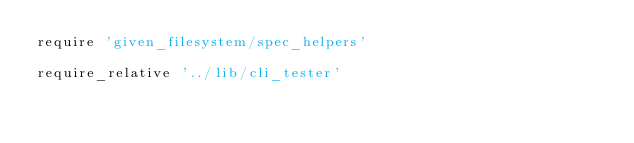Convert code to text. <code><loc_0><loc_0><loc_500><loc_500><_Ruby_>require 'given_filesystem/spec_helpers'

require_relative '../lib/cli_tester'
</code> 